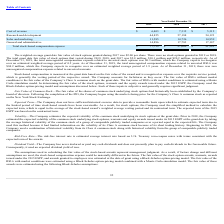According to Fitbit's financial document, What is the expected dividend yield? According to the financial document, Zero. The relevant text states: "of 1.9 years. As of December 31, 2019, there was zero unrecognized compensation expense related to unvested warrants...." Also, What model is used to estimate the fair value of RSUs with market conditions? Monte Carlo simulation model. The document states: "RSUs with market conditions is estimated using a Monte Carlo simulation model. In determining the fair value of the stock options, warrants and the eq..." Also, What is the weighted-average grant date fair value of stock options granted in 2017? According to the financial document, $2.00. The relevant text states: "air value of stock options granted during 2017 was $2.00 per share. There were no stock options granted in 2019 or 2018...." Also, can you calculate: What is the average cost of revenue from 2017-2019? To answer this question, I need to perform calculations using the financial data. The calculation is: (6,403+7,312+5,312)/3, which equals 6342.33 (in thousands). This is based on the information: "Cost of revenue $ 6,403 $ 7,312 $ 5,312 Cost of revenue $ 6,403 $ 7,312 $ 5,312 Cost of revenue $ 6,403 $ 7,312 $ 5,312..." The key data points involved are: 5,312, 6,403, 7,312. Also, can you calculate: What is the difference in research and development costs between 2018 and 2019? Based on the calculation: 57,188-44,855, the result is 12333 (in thousands). This is based on the information: "Research and development 44,855 57,188 54,123 Research and development 44,855 57,188 54,123..." The key data points involved are: 44,855, 57,188. Also, can you calculate: In 2019, what is the percentage constitution of sales and marketing costs among the total stock-based compensation expense? Based on the calculation: 11,585/77,739, the result is 14.9 (percentage). This is based on the information: "Total stock-based compensation expense $ 77,739 $ 97,009 $ 91,581 Sales and marketing 11,585 14,726 14,959..." The key data points involved are: 11,585, 77,739. 